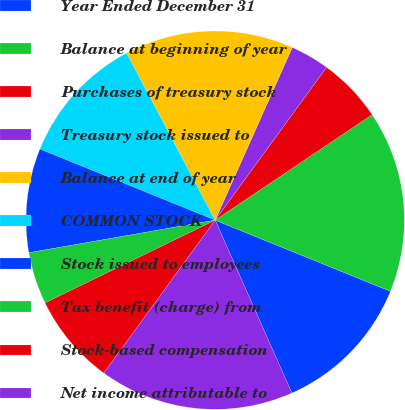Convert chart. <chart><loc_0><loc_0><loc_500><loc_500><pie_chart><fcel>Year Ended December 31<fcel>Balance at beginning of year<fcel>Purchases of treasury stock<fcel>Treasury stock issued to<fcel>Balance at end of year<fcel>COMMON STOCK<fcel>Stock issued to employees<fcel>Tax benefit (charge) from<fcel>Stock-based compensation<fcel>Net income attributable to<nl><fcel>12.22%<fcel>15.55%<fcel>5.56%<fcel>3.34%<fcel>14.44%<fcel>11.11%<fcel>8.89%<fcel>4.45%<fcel>7.78%<fcel>16.66%<nl></chart> 